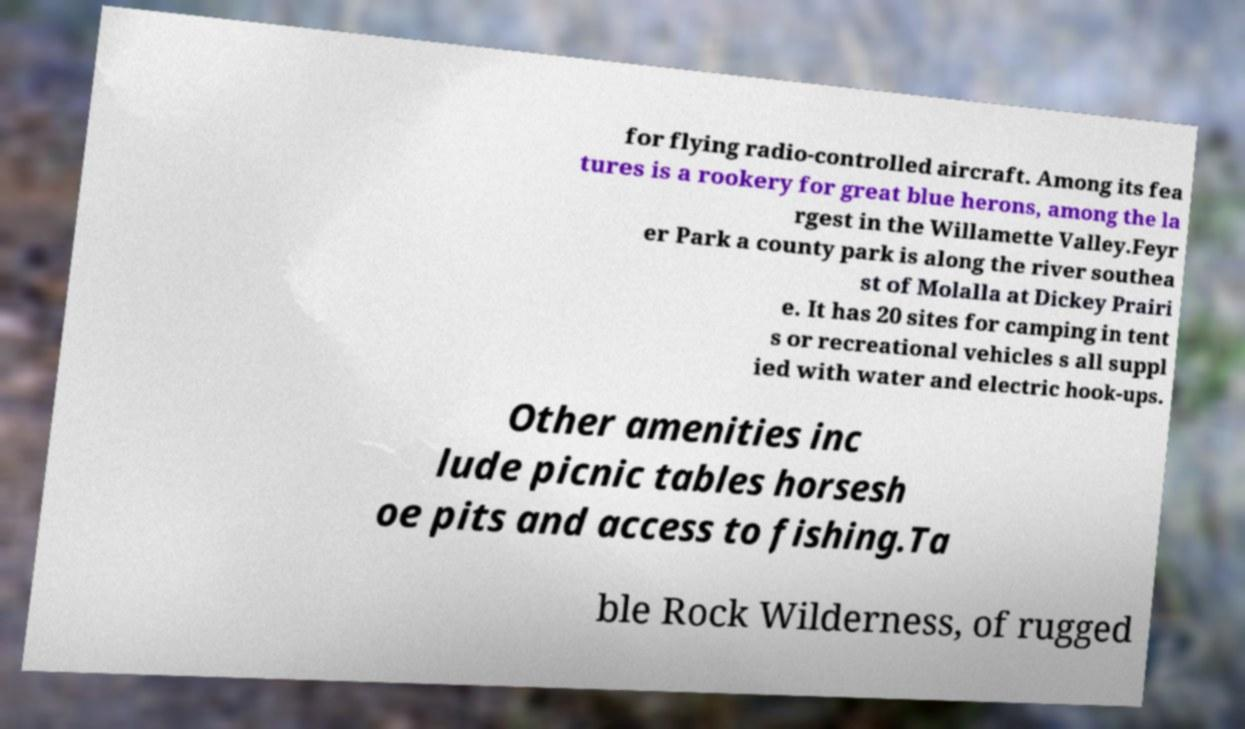Can you accurately transcribe the text from the provided image for me? for flying radio-controlled aircraft. Among its fea tures is a rookery for great blue herons, among the la rgest in the Willamette Valley.Feyr er Park a county park is along the river southea st of Molalla at Dickey Prairi e. It has 20 sites for camping in tent s or recreational vehicles s all suppl ied with water and electric hook-ups. Other amenities inc lude picnic tables horsesh oe pits and access to fishing.Ta ble Rock Wilderness, of rugged 